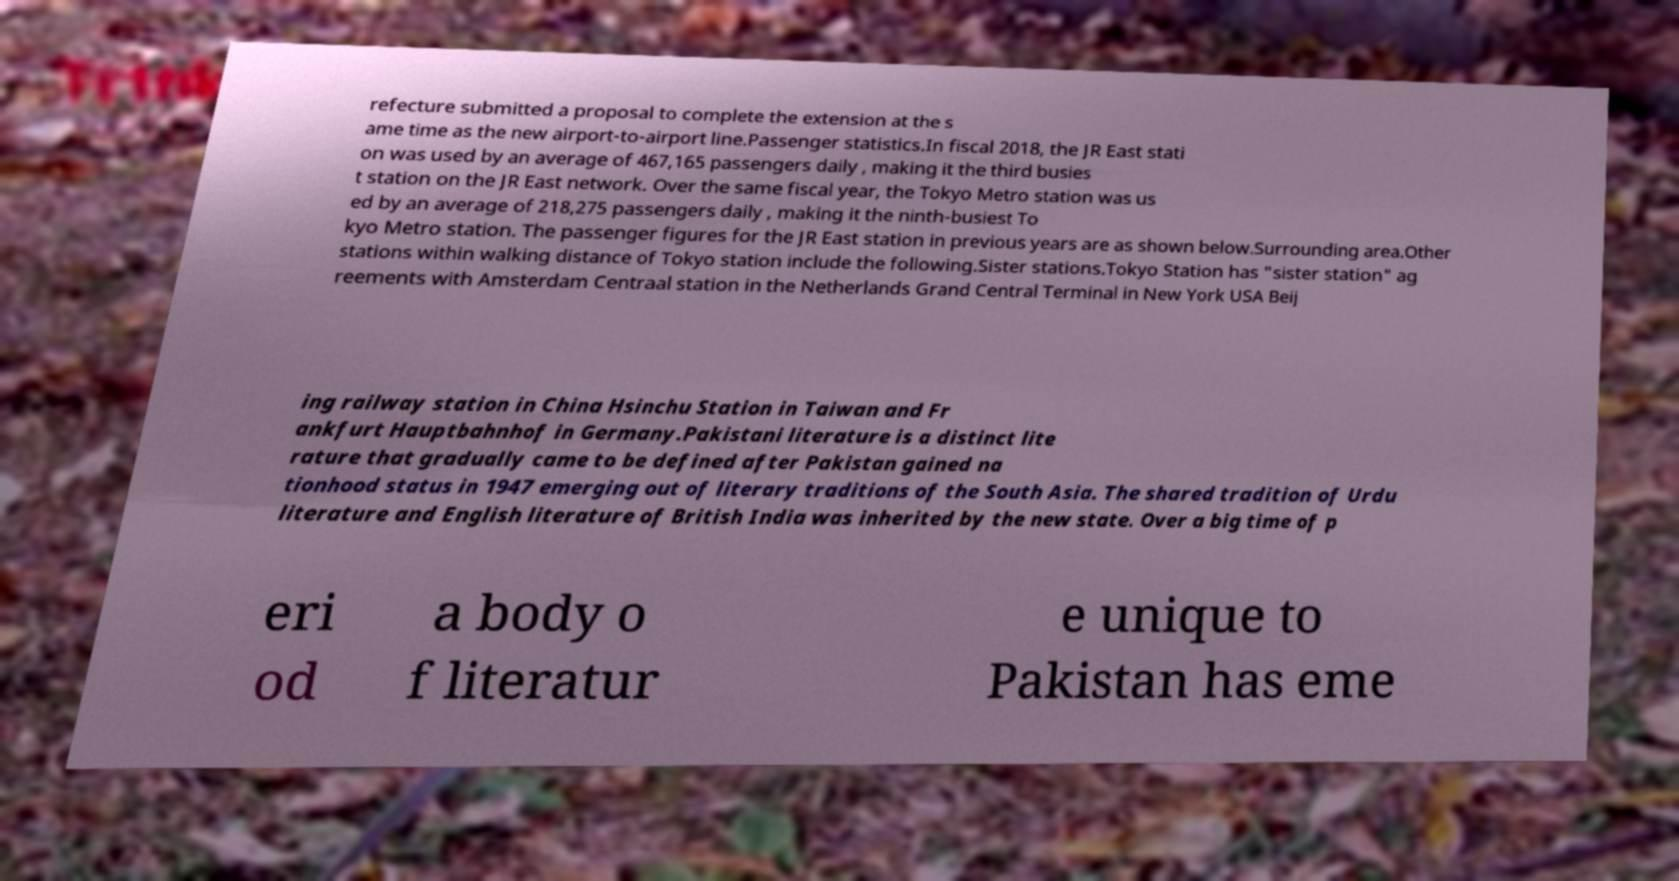What messages or text are displayed in this image? I need them in a readable, typed format. refecture submitted a proposal to complete the extension at the s ame time as the new airport-to-airport line.Passenger statistics.In fiscal 2018, the JR East stati on was used by an average of 467,165 passengers daily , making it the third busies t station on the JR East network. Over the same fiscal year, the Tokyo Metro station was us ed by an average of 218,275 passengers daily , making it the ninth-busiest To kyo Metro station. The passenger figures for the JR East station in previous years are as shown below.Surrounding area.Other stations within walking distance of Tokyo station include the following.Sister stations.Tokyo Station has "sister station" ag reements with Amsterdam Centraal station in the Netherlands Grand Central Terminal in New York USA Beij ing railway station in China Hsinchu Station in Taiwan and Fr ankfurt Hauptbahnhof in Germany.Pakistani literature is a distinct lite rature that gradually came to be defined after Pakistan gained na tionhood status in 1947 emerging out of literary traditions of the South Asia. The shared tradition of Urdu literature and English literature of British India was inherited by the new state. Over a big time of p eri od a body o f literatur e unique to Pakistan has eme 